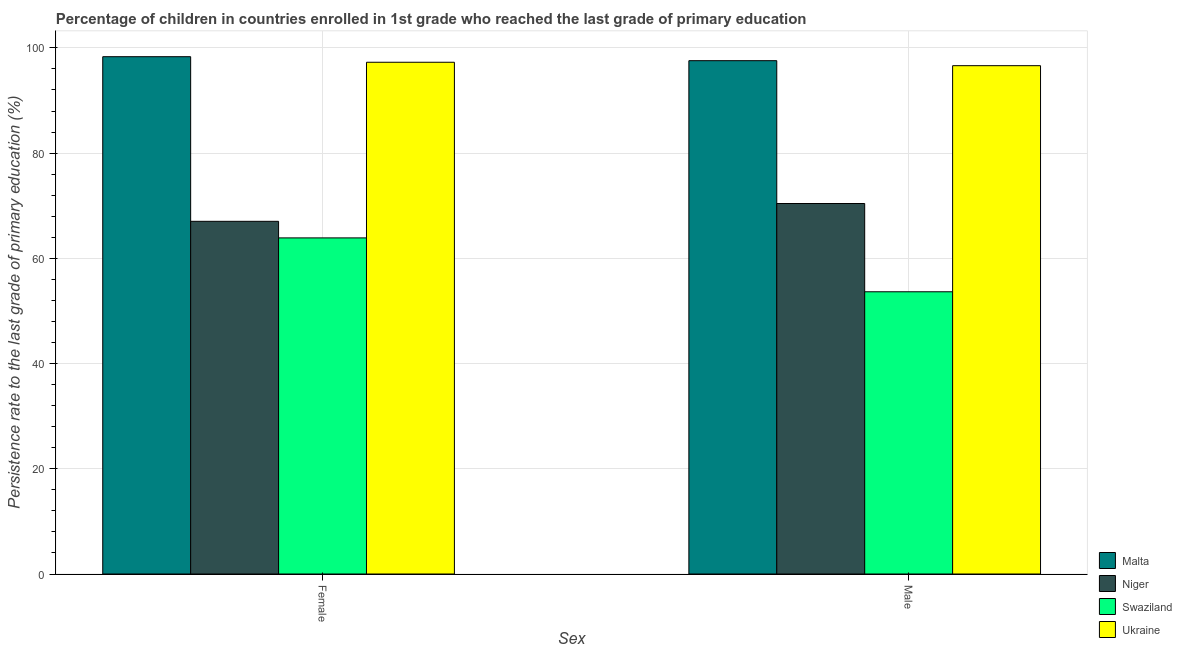How many groups of bars are there?
Keep it short and to the point. 2. Are the number of bars on each tick of the X-axis equal?
Offer a terse response. Yes. How many bars are there on the 2nd tick from the right?
Your response must be concise. 4. What is the persistence rate of female students in Swaziland?
Offer a terse response. 63.88. Across all countries, what is the maximum persistence rate of male students?
Ensure brevity in your answer.  97.57. Across all countries, what is the minimum persistence rate of male students?
Ensure brevity in your answer.  53.64. In which country was the persistence rate of female students maximum?
Offer a terse response. Malta. In which country was the persistence rate of male students minimum?
Keep it short and to the point. Swaziland. What is the total persistence rate of female students in the graph?
Your answer should be compact. 326.5. What is the difference between the persistence rate of female students in Malta and that in Niger?
Your response must be concise. 31.29. What is the difference between the persistence rate of male students in Malta and the persistence rate of female students in Swaziland?
Provide a succinct answer. 33.68. What is the average persistence rate of male students per country?
Your answer should be compact. 79.56. What is the difference between the persistence rate of male students and persistence rate of female students in Malta?
Your answer should be compact. -0.76. In how many countries, is the persistence rate of female students greater than 12 %?
Make the answer very short. 4. What is the ratio of the persistence rate of male students in Swaziland to that in Niger?
Give a very brief answer. 0.76. What does the 4th bar from the left in Male represents?
Your answer should be very brief. Ukraine. What does the 1st bar from the right in Female represents?
Offer a terse response. Ukraine. Are all the bars in the graph horizontal?
Offer a very short reply. No. How many countries are there in the graph?
Provide a succinct answer. 4. What is the difference between two consecutive major ticks on the Y-axis?
Give a very brief answer. 20. Are the values on the major ticks of Y-axis written in scientific E-notation?
Offer a terse response. No. Does the graph contain grids?
Your response must be concise. Yes. How many legend labels are there?
Offer a very short reply. 4. How are the legend labels stacked?
Offer a terse response. Vertical. What is the title of the graph?
Give a very brief answer. Percentage of children in countries enrolled in 1st grade who reached the last grade of primary education. Does "Hong Kong" appear as one of the legend labels in the graph?
Your answer should be very brief. No. What is the label or title of the X-axis?
Make the answer very short. Sex. What is the label or title of the Y-axis?
Keep it short and to the point. Persistence rate to the last grade of primary education (%). What is the Persistence rate to the last grade of primary education (%) of Malta in Female?
Make the answer very short. 98.32. What is the Persistence rate to the last grade of primary education (%) of Niger in Female?
Your answer should be very brief. 67.03. What is the Persistence rate to the last grade of primary education (%) in Swaziland in Female?
Keep it short and to the point. 63.88. What is the Persistence rate to the last grade of primary education (%) in Ukraine in Female?
Keep it short and to the point. 97.27. What is the Persistence rate to the last grade of primary education (%) in Malta in Male?
Give a very brief answer. 97.57. What is the Persistence rate to the last grade of primary education (%) of Niger in Male?
Your response must be concise. 70.42. What is the Persistence rate to the last grade of primary education (%) in Swaziland in Male?
Offer a terse response. 53.64. What is the Persistence rate to the last grade of primary education (%) of Ukraine in Male?
Provide a short and direct response. 96.61. Across all Sex, what is the maximum Persistence rate to the last grade of primary education (%) of Malta?
Provide a short and direct response. 98.32. Across all Sex, what is the maximum Persistence rate to the last grade of primary education (%) of Niger?
Your answer should be very brief. 70.42. Across all Sex, what is the maximum Persistence rate to the last grade of primary education (%) in Swaziland?
Keep it short and to the point. 63.88. Across all Sex, what is the maximum Persistence rate to the last grade of primary education (%) in Ukraine?
Your answer should be compact. 97.27. Across all Sex, what is the minimum Persistence rate to the last grade of primary education (%) of Malta?
Make the answer very short. 97.57. Across all Sex, what is the minimum Persistence rate to the last grade of primary education (%) of Niger?
Provide a short and direct response. 67.03. Across all Sex, what is the minimum Persistence rate to the last grade of primary education (%) in Swaziland?
Make the answer very short. 53.64. Across all Sex, what is the minimum Persistence rate to the last grade of primary education (%) in Ukraine?
Offer a very short reply. 96.61. What is the total Persistence rate to the last grade of primary education (%) of Malta in the graph?
Ensure brevity in your answer.  195.89. What is the total Persistence rate to the last grade of primary education (%) of Niger in the graph?
Your answer should be compact. 137.45. What is the total Persistence rate to the last grade of primary education (%) in Swaziland in the graph?
Offer a very short reply. 117.52. What is the total Persistence rate to the last grade of primary education (%) in Ukraine in the graph?
Keep it short and to the point. 193.88. What is the difference between the Persistence rate to the last grade of primary education (%) of Malta in Female and that in Male?
Offer a terse response. 0.76. What is the difference between the Persistence rate to the last grade of primary education (%) in Niger in Female and that in Male?
Provide a short and direct response. -3.39. What is the difference between the Persistence rate to the last grade of primary education (%) in Swaziland in Female and that in Male?
Your response must be concise. 10.24. What is the difference between the Persistence rate to the last grade of primary education (%) in Ukraine in Female and that in Male?
Give a very brief answer. 0.65. What is the difference between the Persistence rate to the last grade of primary education (%) in Malta in Female and the Persistence rate to the last grade of primary education (%) in Niger in Male?
Provide a short and direct response. 27.91. What is the difference between the Persistence rate to the last grade of primary education (%) of Malta in Female and the Persistence rate to the last grade of primary education (%) of Swaziland in Male?
Provide a short and direct response. 44.68. What is the difference between the Persistence rate to the last grade of primary education (%) of Malta in Female and the Persistence rate to the last grade of primary education (%) of Ukraine in Male?
Provide a succinct answer. 1.71. What is the difference between the Persistence rate to the last grade of primary education (%) in Niger in Female and the Persistence rate to the last grade of primary education (%) in Swaziland in Male?
Ensure brevity in your answer.  13.39. What is the difference between the Persistence rate to the last grade of primary education (%) of Niger in Female and the Persistence rate to the last grade of primary education (%) of Ukraine in Male?
Make the answer very short. -29.58. What is the difference between the Persistence rate to the last grade of primary education (%) of Swaziland in Female and the Persistence rate to the last grade of primary education (%) of Ukraine in Male?
Provide a short and direct response. -32.73. What is the average Persistence rate to the last grade of primary education (%) in Malta per Sex?
Provide a short and direct response. 97.94. What is the average Persistence rate to the last grade of primary education (%) in Niger per Sex?
Make the answer very short. 68.73. What is the average Persistence rate to the last grade of primary education (%) in Swaziland per Sex?
Provide a short and direct response. 58.76. What is the average Persistence rate to the last grade of primary education (%) of Ukraine per Sex?
Provide a short and direct response. 96.94. What is the difference between the Persistence rate to the last grade of primary education (%) in Malta and Persistence rate to the last grade of primary education (%) in Niger in Female?
Your answer should be compact. 31.29. What is the difference between the Persistence rate to the last grade of primary education (%) in Malta and Persistence rate to the last grade of primary education (%) in Swaziland in Female?
Provide a succinct answer. 34.44. What is the difference between the Persistence rate to the last grade of primary education (%) of Malta and Persistence rate to the last grade of primary education (%) of Ukraine in Female?
Provide a succinct answer. 1.06. What is the difference between the Persistence rate to the last grade of primary education (%) in Niger and Persistence rate to the last grade of primary education (%) in Swaziland in Female?
Keep it short and to the point. 3.15. What is the difference between the Persistence rate to the last grade of primary education (%) of Niger and Persistence rate to the last grade of primary education (%) of Ukraine in Female?
Your answer should be very brief. -30.23. What is the difference between the Persistence rate to the last grade of primary education (%) of Swaziland and Persistence rate to the last grade of primary education (%) of Ukraine in Female?
Ensure brevity in your answer.  -33.38. What is the difference between the Persistence rate to the last grade of primary education (%) in Malta and Persistence rate to the last grade of primary education (%) in Niger in Male?
Offer a very short reply. 27.15. What is the difference between the Persistence rate to the last grade of primary education (%) of Malta and Persistence rate to the last grade of primary education (%) of Swaziland in Male?
Your answer should be compact. 43.92. What is the difference between the Persistence rate to the last grade of primary education (%) in Malta and Persistence rate to the last grade of primary education (%) in Ukraine in Male?
Ensure brevity in your answer.  0.95. What is the difference between the Persistence rate to the last grade of primary education (%) in Niger and Persistence rate to the last grade of primary education (%) in Swaziland in Male?
Offer a terse response. 16.78. What is the difference between the Persistence rate to the last grade of primary education (%) of Niger and Persistence rate to the last grade of primary education (%) of Ukraine in Male?
Offer a terse response. -26.2. What is the difference between the Persistence rate to the last grade of primary education (%) of Swaziland and Persistence rate to the last grade of primary education (%) of Ukraine in Male?
Keep it short and to the point. -42.97. What is the ratio of the Persistence rate to the last grade of primary education (%) of Malta in Female to that in Male?
Provide a succinct answer. 1.01. What is the ratio of the Persistence rate to the last grade of primary education (%) of Niger in Female to that in Male?
Make the answer very short. 0.95. What is the ratio of the Persistence rate to the last grade of primary education (%) of Swaziland in Female to that in Male?
Your answer should be compact. 1.19. What is the ratio of the Persistence rate to the last grade of primary education (%) in Ukraine in Female to that in Male?
Your answer should be very brief. 1.01. What is the difference between the highest and the second highest Persistence rate to the last grade of primary education (%) of Malta?
Provide a short and direct response. 0.76. What is the difference between the highest and the second highest Persistence rate to the last grade of primary education (%) in Niger?
Your answer should be compact. 3.39. What is the difference between the highest and the second highest Persistence rate to the last grade of primary education (%) of Swaziland?
Your response must be concise. 10.24. What is the difference between the highest and the second highest Persistence rate to the last grade of primary education (%) in Ukraine?
Offer a very short reply. 0.65. What is the difference between the highest and the lowest Persistence rate to the last grade of primary education (%) in Malta?
Your answer should be very brief. 0.76. What is the difference between the highest and the lowest Persistence rate to the last grade of primary education (%) in Niger?
Your answer should be compact. 3.39. What is the difference between the highest and the lowest Persistence rate to the last grade of primary education (%) in Swaziland?
Your answer should be compact. 10.24. What is the difference between the highest and the lowest Persistence rate to the last grade of primary education (%) of Ukraine?
Provide a short and direct response. 0.65. 